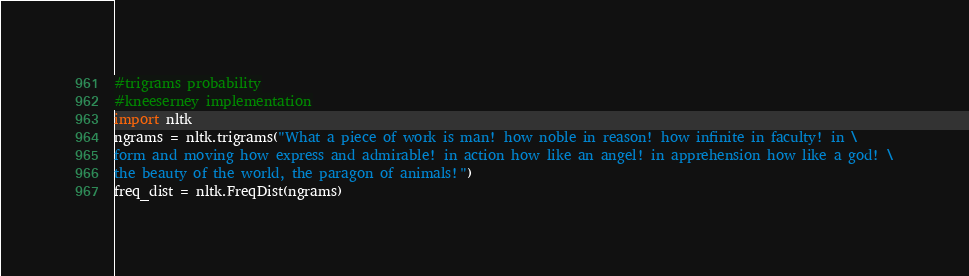Convert code to text. <code><loc_0><loc_0><loc_500><loc_500><_Python_>#trigrams probability
#kneeserney implementation
import nltk
ngrams = nltk.trigrams("What a piece of work is man! how noble in reason! how infinite in faculty! in \
form and moving how express and admirable! in action how like an angel! in apprehension how like a god! \
the beauty of the world, the paragon of animals!")
freq_dist = nltk.FreqDist(ngrams)</code> 